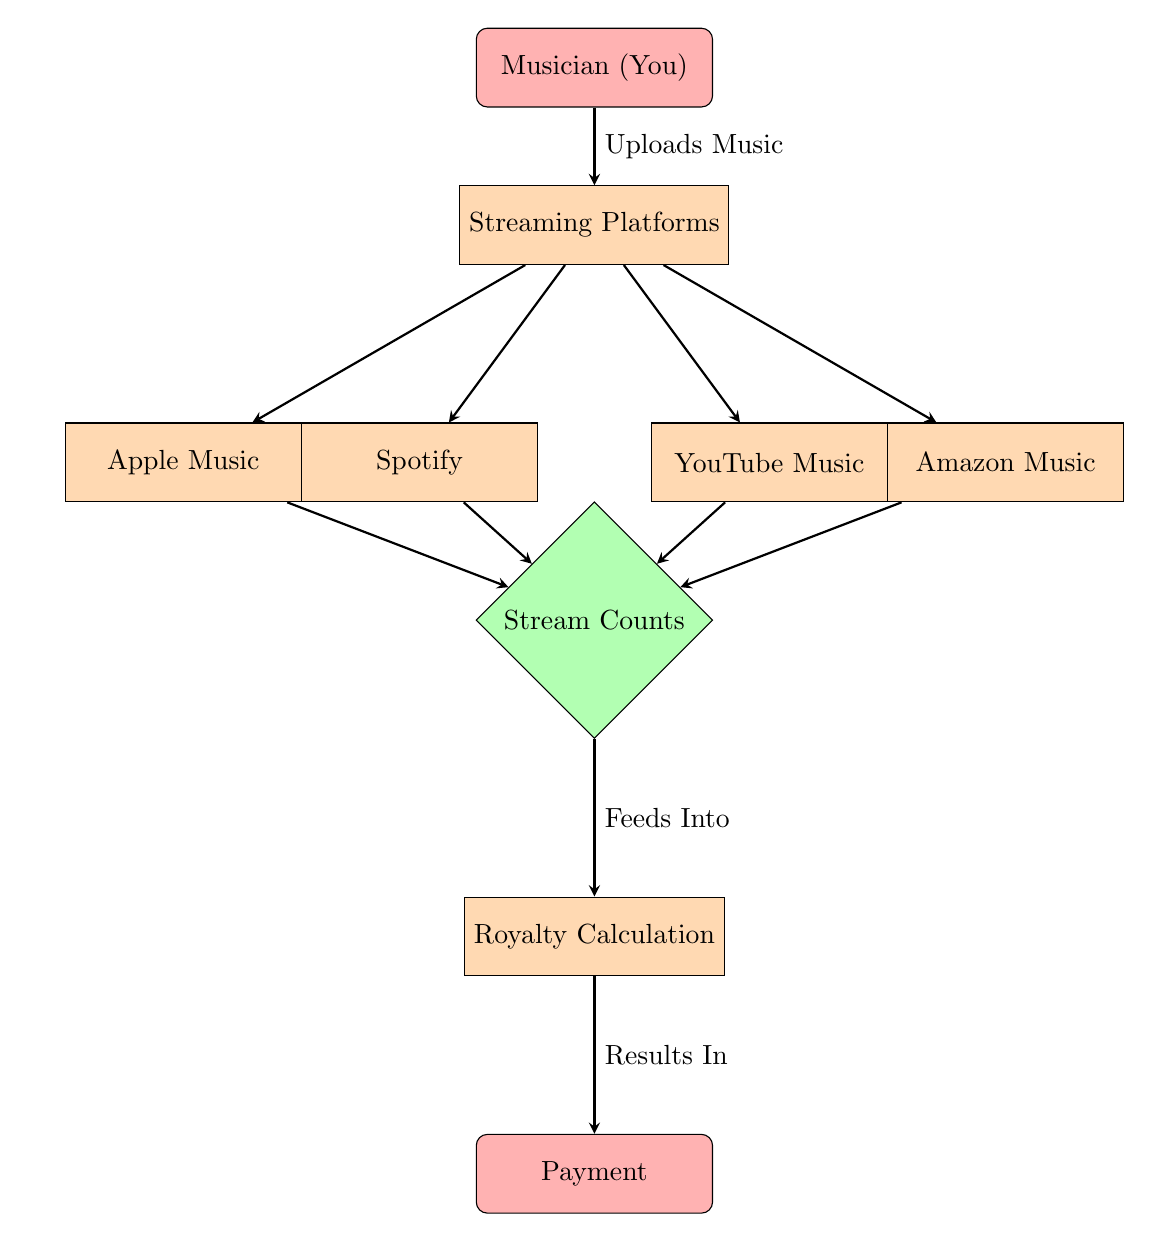What is the first node in the flow chart? The flow chart begins with the node labeled "Musician (You)". This node represents the starting point of the process.
Answer: Musician (You) How many streaming platforms are listed in the diagram? There are four streaming platforms shown in the diagram: Spotify, Apple Music, YouTube Music, and Amazon Music. This can be counted directly from the nodes connecting to "Platforms".
Answer: Four What does the node "Stream Counts" represent? The "Stream Counts" node is a decision node, which indicates that it generates data from the streams for each specific platform. It is crucial for determining the revenue based on streaming activity.
Answer: Data generation Which node contains the process of calculation to arrive at revenue? The "Royalty Calculation" node represents the process of calculating the royalties that a musician earns based on the stream counts from different platforms. This node receives information from "Stream Counts".
Answer: Royalty Calculation What is the final output of the flow chart? The final output, represented at the end of the flow chart, is the "Payment" node, which signifies the end of the process where payment is made based on the calculation of royalties.
Answer: Payment What action does the musician take to start the process? The musician starts the process by uploading music to the streaming platforms, as shown by the connection from "Musician (You)" to "Streaming Platforms".
Answer: Uploads Music Which platform generates data for calculating royalties? All four platforms: Spotify, Apple Music, YouTube Music, and Amazon Music generate data for calculating royalties, as they each connect to the "Stream Counts" node.
Answer: All platforms What does the "Feeds Into" label indicate? The "Feeds Into" label indicates the flow of information from the "Stream Counts" to the "Royalty Calculation" process, signifying that the stream data is used to calculate royalties.
Answer: Data flow What kind of node is "Stream Counts"? The "Stream Counts" node is categorized as a decision node, which is indicated by its diamond shape in the flow chart. This means it processes information generated from the streaming platforms.
Answer: Decision node 